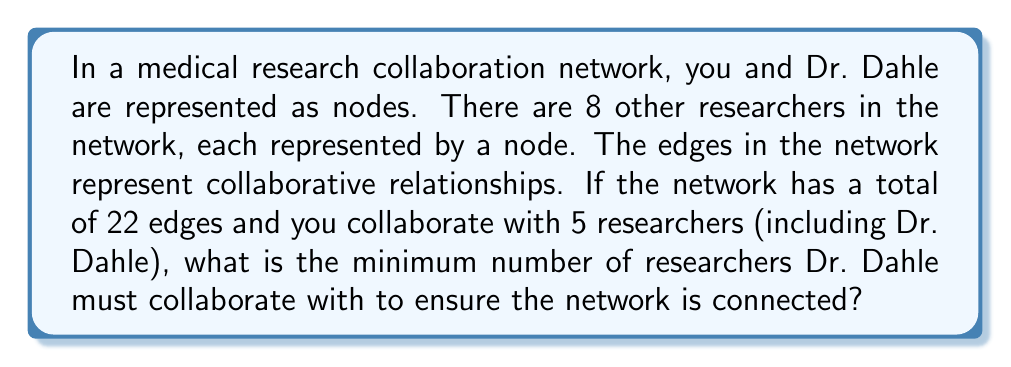Could you help me with this problem? Let's approach this step-by-step:

1) First, let's define our variables:
   $n$ = total number of nodes (researchers) = 10
   $e$ = total number of edges (collaborations) = 22
   $c_y$ = your collaborations = 5
   $c_d$ = Dr. Dahle's collaborations (unknown)

2) For a graph to be connected, it must have at least $n-1$ edges. In this case:
   Minimum edges for connectivity = $10 - 1 = 9$

3) We know the total edges is 22, which is more than the minimum required. However, we need to ensure that these edges connect all nodes.

4) You are connected to 5 researchers (including Dr. Dahle). This means there are 4 other researchers you're directly connected to.

5) For the network to be connected, Dr. Dahle must be connected to all the researchers you're not connected to, plus you.
   Researchers not connected to you = $10 - 5 = 5$

6) Therefore, the minimum number of researchers Dr. Dahle must collaborate with is:
   $c_d = 5 + 1 = 6$

7) We can verify this:
   - You are connected to 5 researchers (including Dr. Dahle)
   - Dr. Dahle is connected to 6 researchers (including you)
   - This ensures all 10 researchers are in the network

8) The total number of unique edges in this configuration would be:
   $e = c_y + c_d - 1 = 5 + 6 - 1 = 10$
   (We subtract 1 to avoid double-counting the edge between you and Dr. Dahle)

9) This is greater than the minimum required (9), so it satisfies the connectivity condition.
Answer: Dr. Dahle must collaborate with at least 6 researchers to ensure the network is connected. 